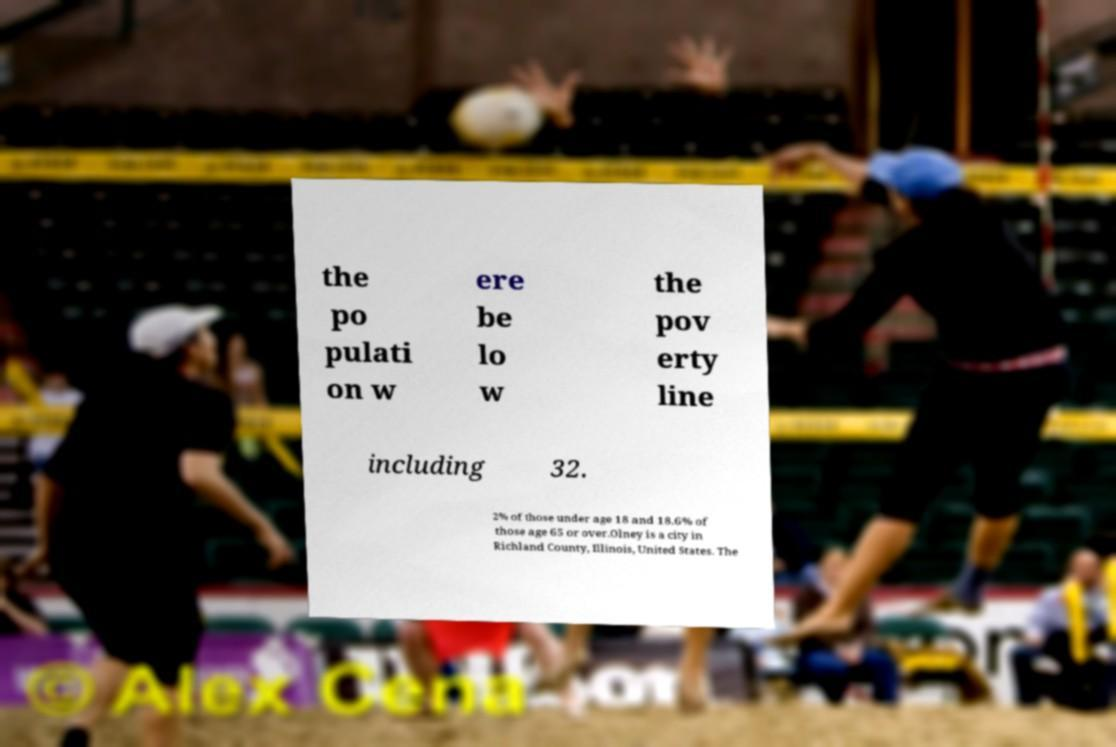There's text embedded in this image that I need extracted. Can you transcribe it verbatim? the po pulati on w ere be lo w the pov erty line including 32. 2% of those under age 18 and 18.6% of those age 65 or over.Olney is a city in Richland County, Illinois, United States. The 